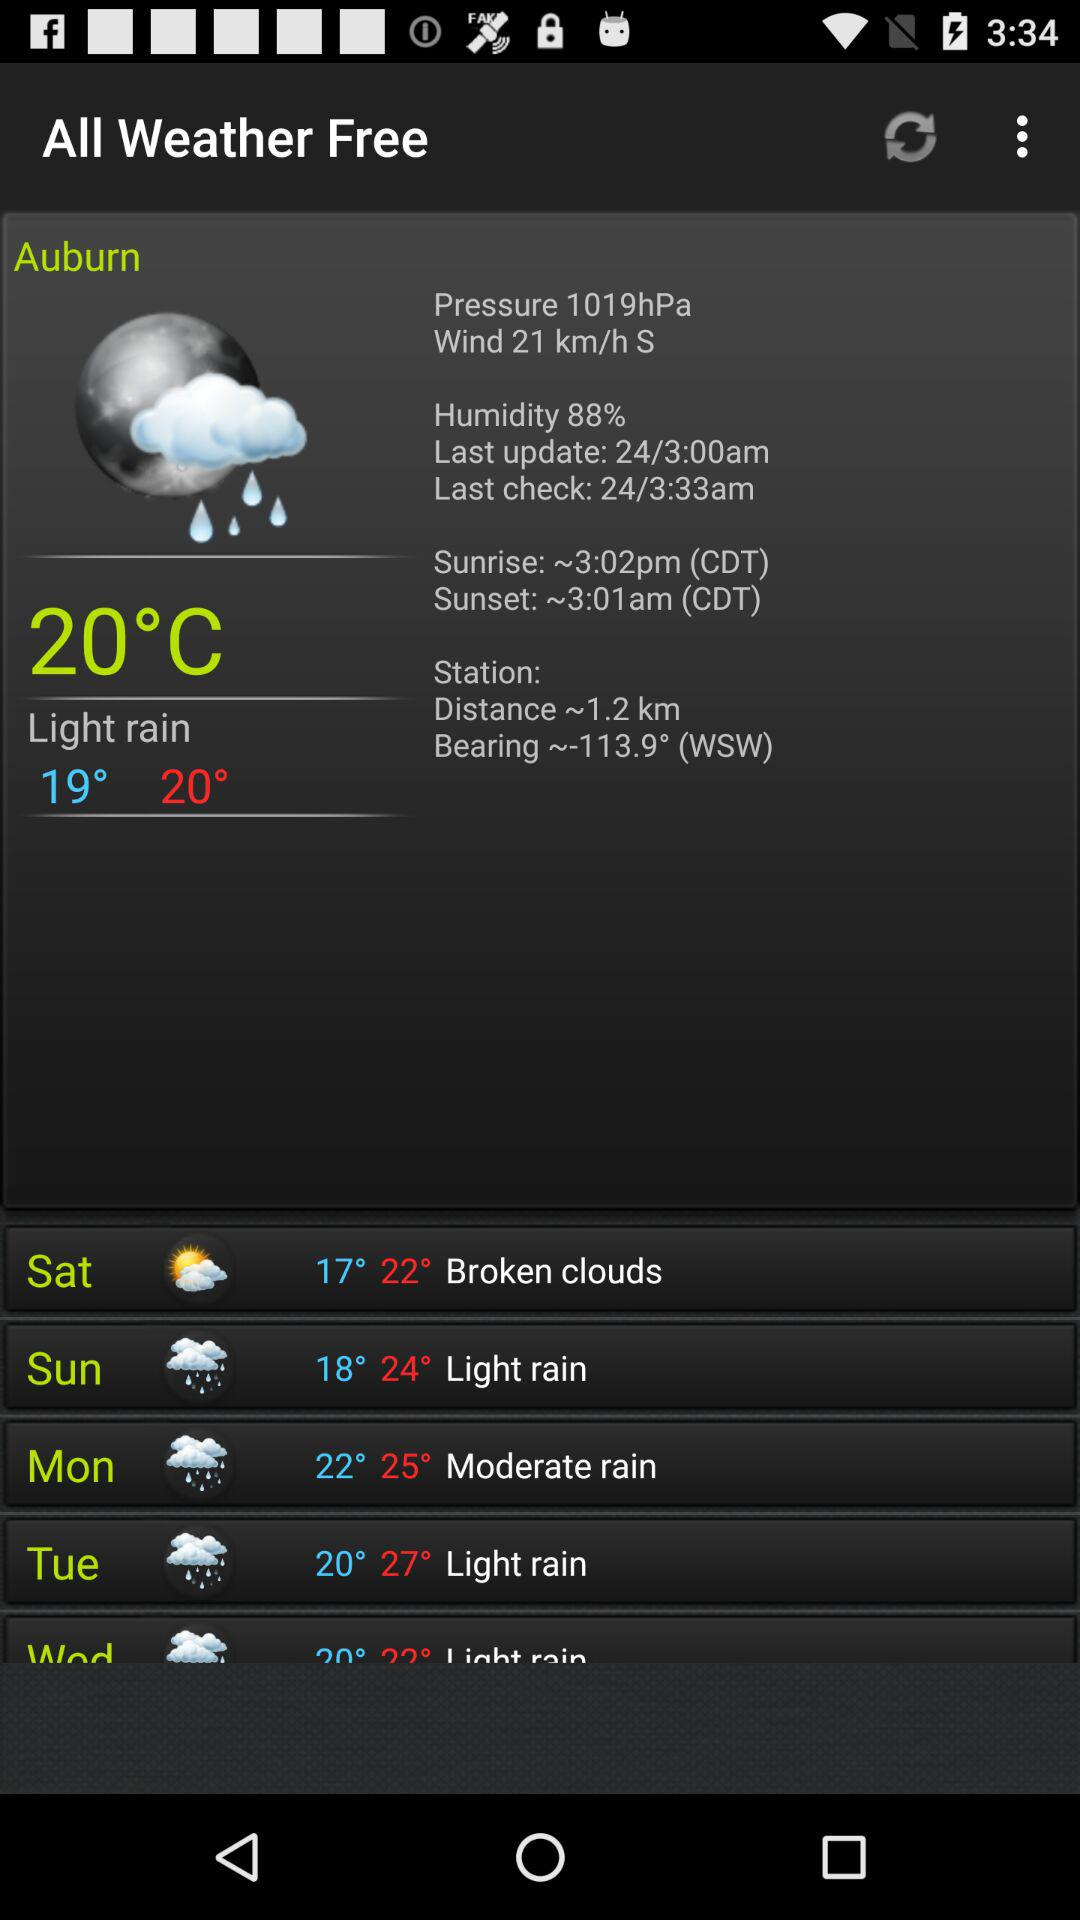What is the highest recorded temperature on Monday? The highest recorded temperature on Monday is 25°. 